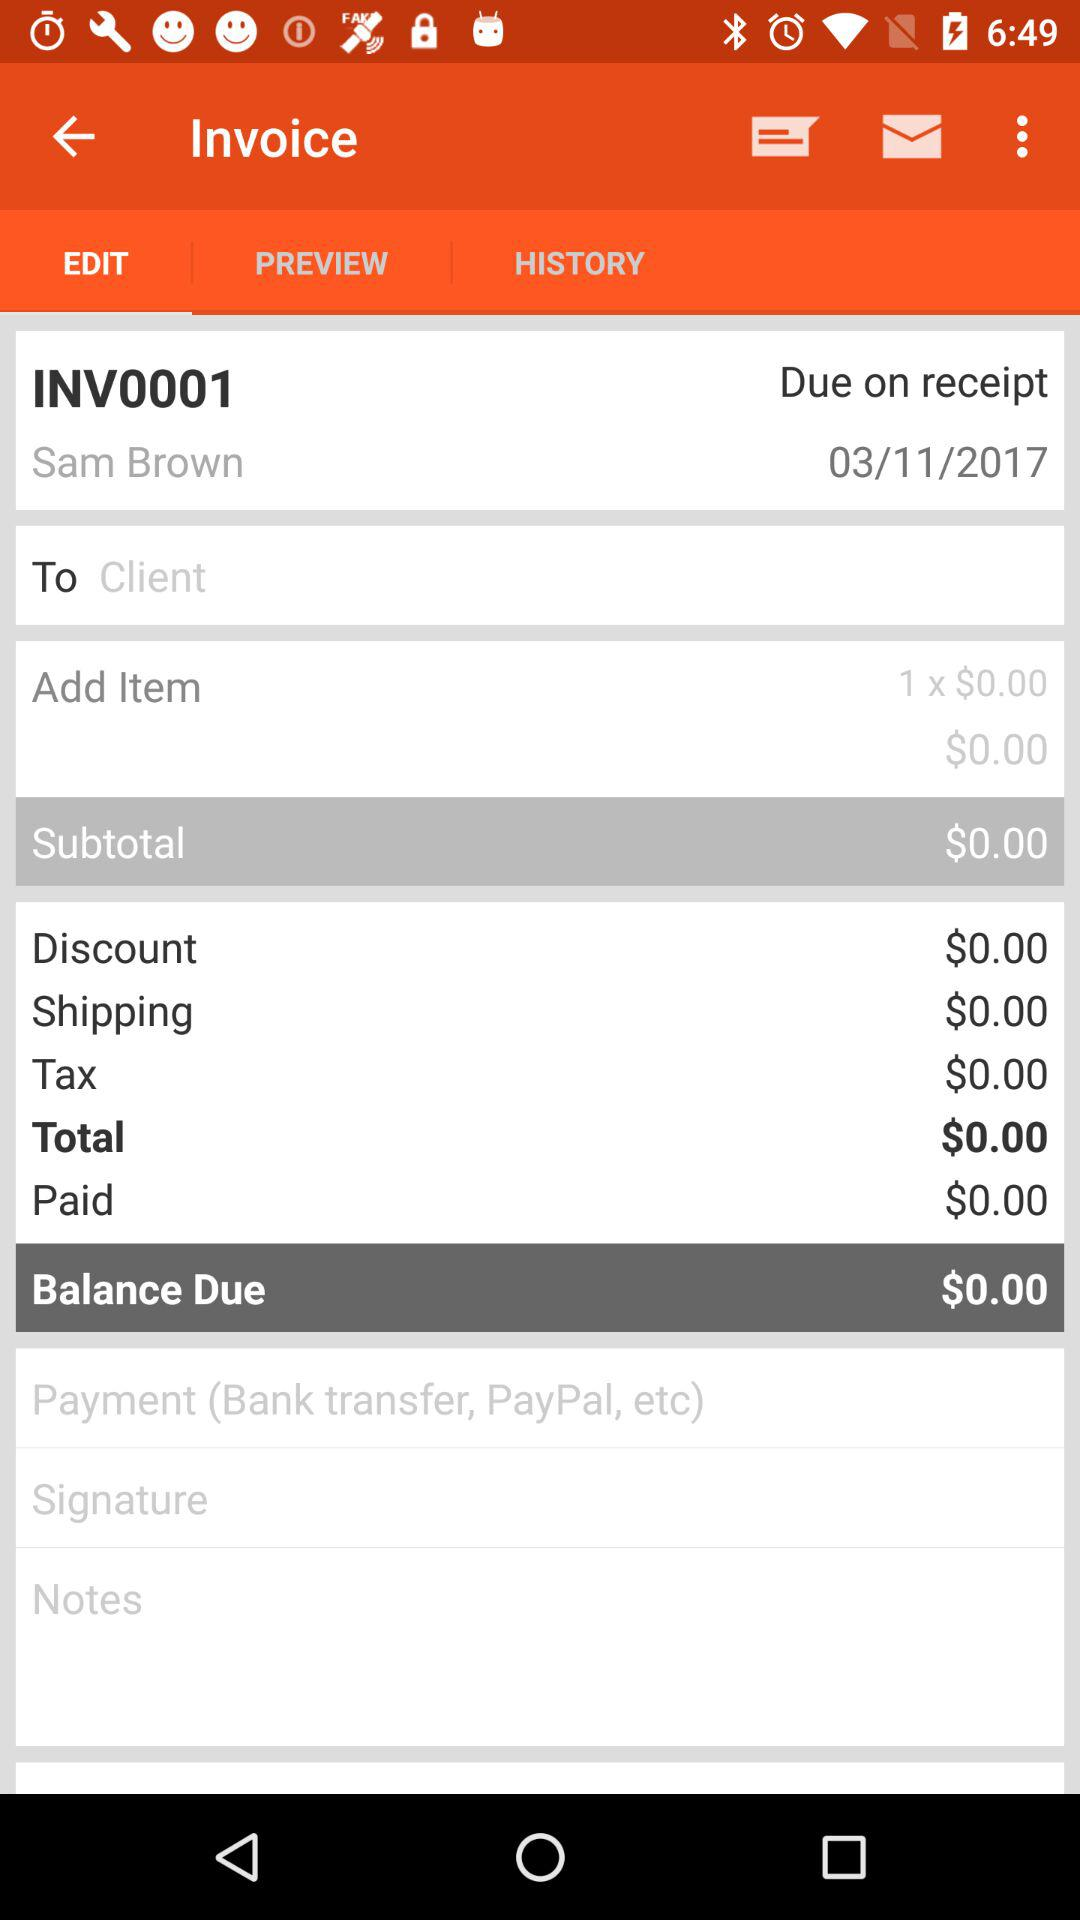What is the balance due on this invoice?
Answer the question using a single word or phrase. $0.00 